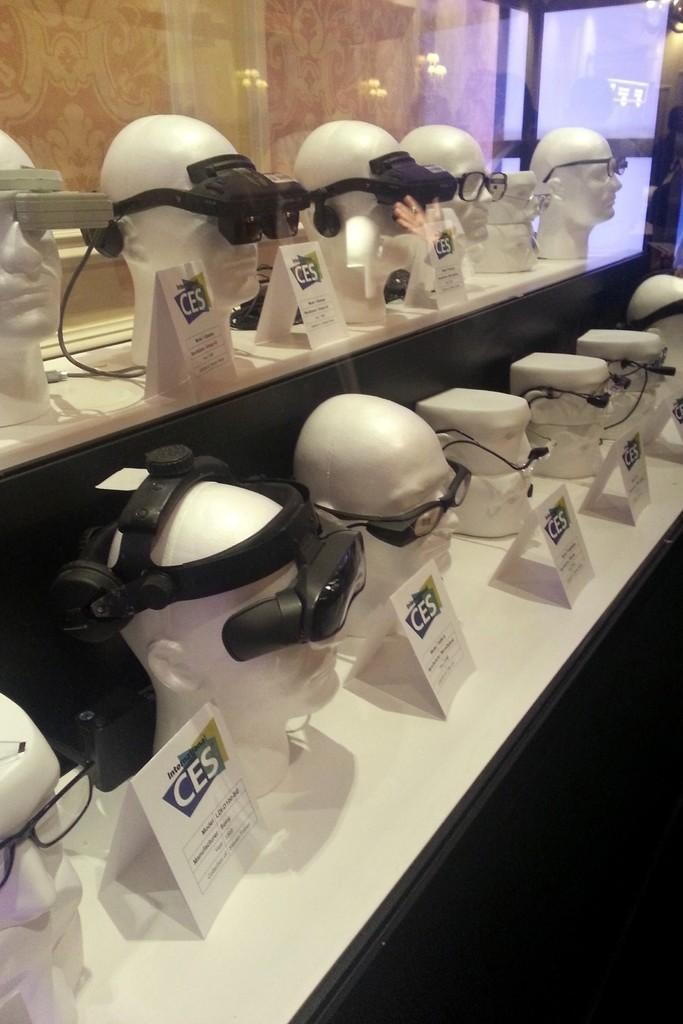What objects are on display in the image? There are different types of glasses on mannequins in the image. Where can we find information about the prices of the glasses? Price tags are present on a white surface in the image. Can you describe the background of the image? There is a glass in the background of the image. What type of government is depicted in the image? There is no depiction of a government in the image; it features glasses on mannequins and price tags on a white surface. 